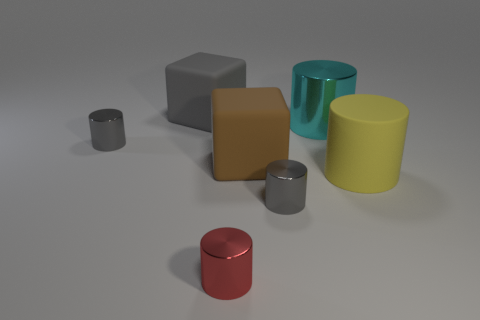If I were to group these objects by color, which groups would they fall into? You could create three color groups from these objects. The first would include the gray and silver cylinders due to their neutral tones. The second group would comprise the yellow and gold cylinders for their warm, yellow-based colors. Lastly, the red and cyan cylinders would form a group of more vivid and distinct colors, each standing out on its own. 